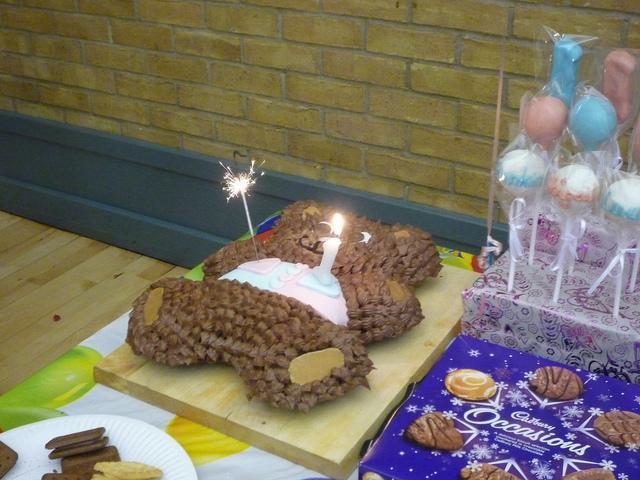What is the cake in the shape of?
From the following four choices, select the correct answer to address the question.
Options: Elephant, bear, cat, dog. Bear. 